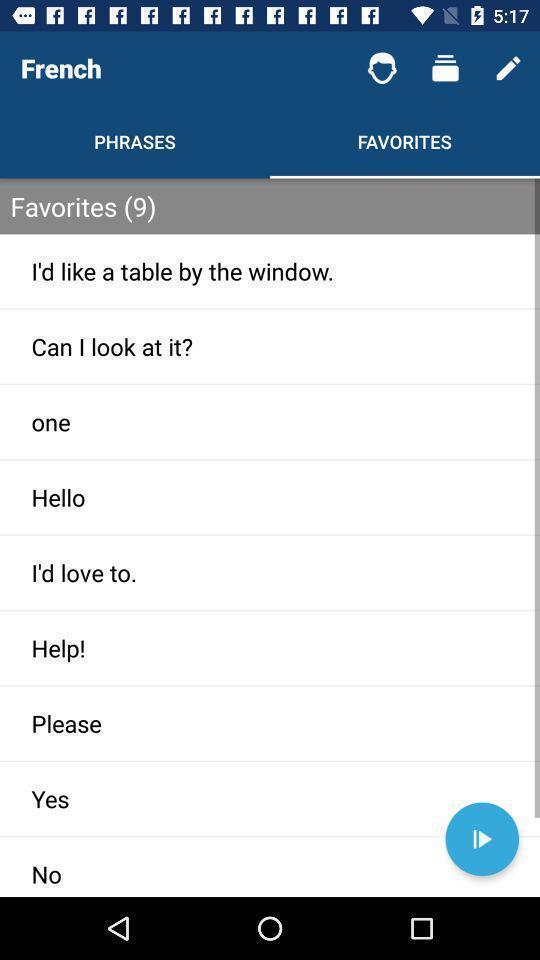What is the overall content of this screenshot? Screen page of a learning application. 